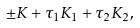Convert formula to latex. <formula><loc_0><loc_0><loc_500><loc_500>\pm K + \tau _ { 1 } K _ { 1 } + \tau _ { 2 } K _ { 2 } ,</formula> 